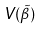<formula> <loc_0><loc_0><loc_500><loc_500>V ( \tilde { \beta } )</formula> 